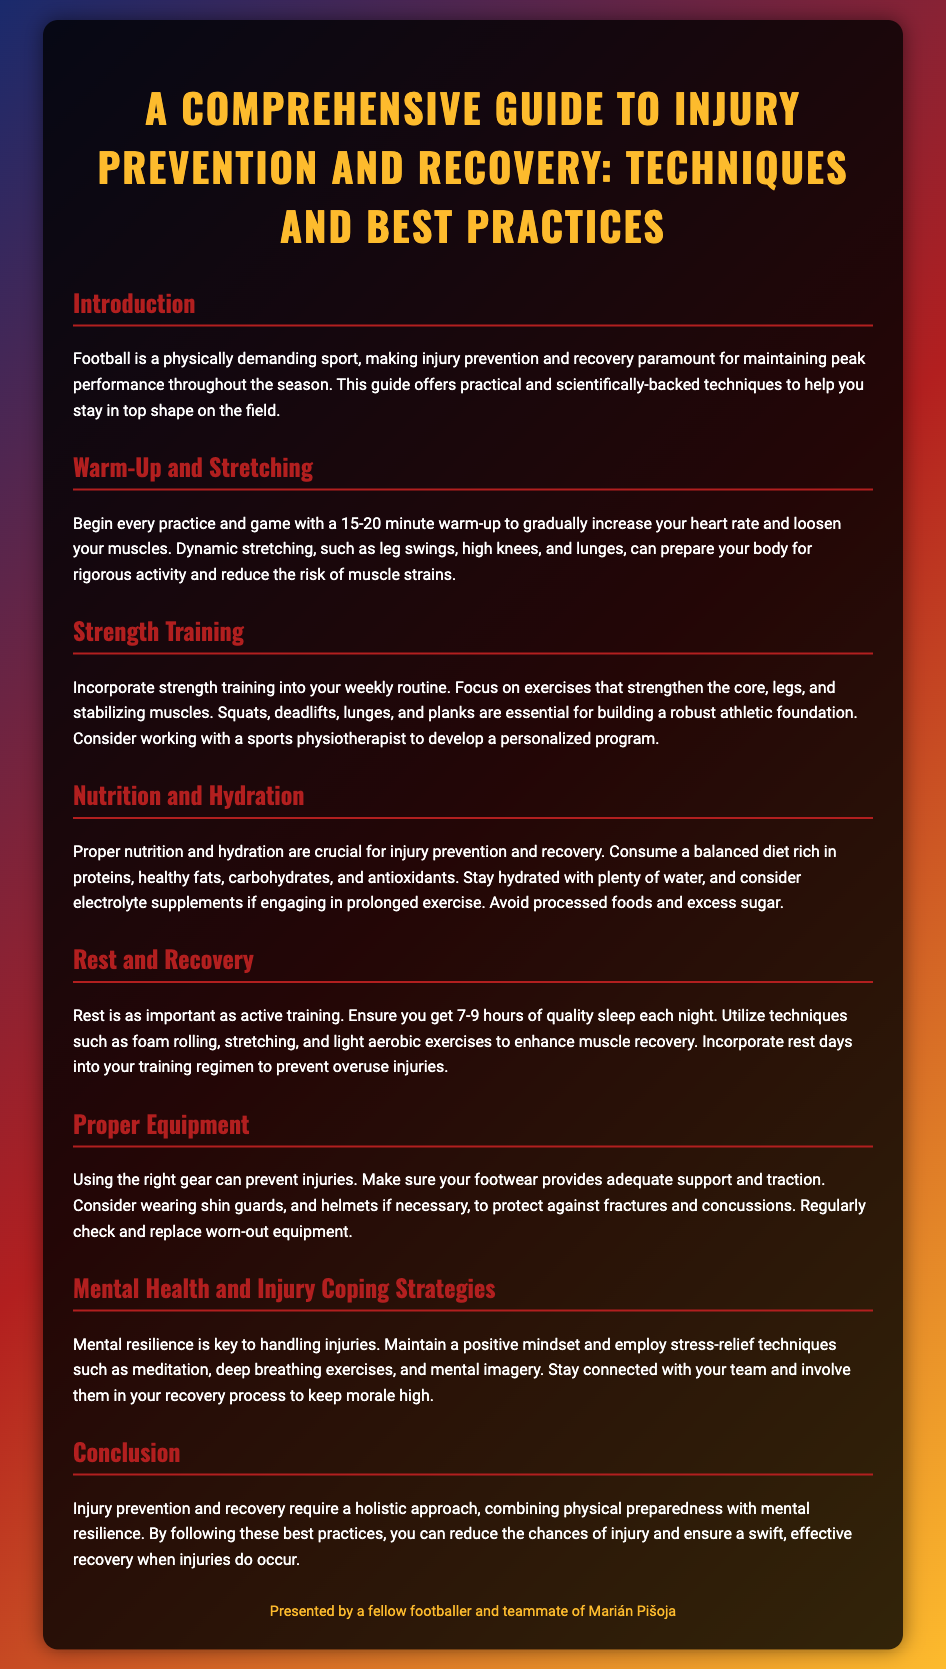What is the title of the guide? The title is displayed prominently at the top of the document, identifying the primary focus of the content.
Answer: A Comprehensive Guide to Injury Prevention and Recovery: Techniques and Best Practices How long should a warm-up last? The section on Warm-Up and Stretching specifies the recommended duration for a warm-up before activities.
Answer: 15-20 minutes What type of stretching is recommended before playing? In the Warm-Up and Stretching section, the types of stretching suggested are aimed at preparing the body for activity.
Answer: Dynamic stretching What are essential exercises mentioned for strength training? The Strength Training section lists important exercises that contribute to building strength in key areas of the body.
Answer: Squats, deadlifts, lunges, and planks What is the recommended amount of sleep for recovery? The Rest and Recovery section outlines the necessary amount of sleep to support recovery processes effectively.
Answer: 7-9 hours What is a key factor in mental health during recovery? The Mental Health and Injury Coping Strategies section discusses an important aspect of maintaining a positive state while recovering.
Answer: Positive mindset Who presented the guide? The footer credits the presenter, indicating a personal connection to the football community.
Answer: A fellow footballer and teammate of Marián Pišoja What should be included in a balanced diet for athletes? The Nutrition and Hydration section emphasizes specific dietary components crucial for performance and recovery.
Answer: Proteins, healthy fats, carbohydrates, and antioxidants What is a benefit of using proper equipment? The Proper Equipment section highlights a critical advantage that comes from using correctly fitted sports gear while playing.
Answer: Prevent injuries 